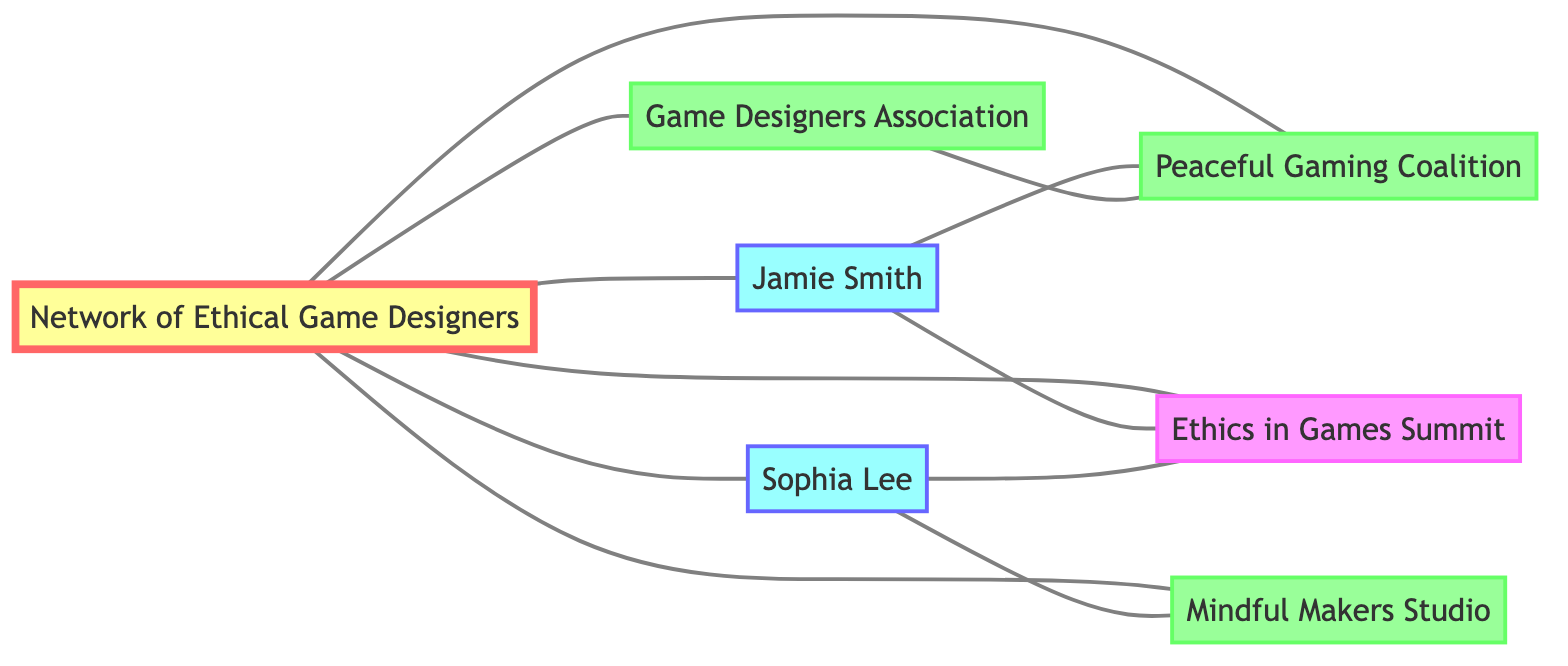What is the total number of nodes in the diagram? The diagram lists a total of seven unique nodes: the Network of Ethical Game Designers, Jamie Smith, Sophia Lee, Ethics in Games Summit, Peaceful Gaming Coalition, Game Designers Association, and Mindful Makers Studio. Therefore, the total number of nodes is seven.
Answer: 7 How many edges connect Jamie Smith to other nodes? Jamie Smith is connected to four different nodes: the Network of Ethical Game Designers, Peaceful Gaming Coalition, Ethics in Games Summit, and the overall game designers network. Counting these connections gives a total of four edges.
Answer: 4 What organization is connected to both Jamie Smith and Sophia Lee? The Peaceful Gaming Coalition is the only organization connected to both Jamie Smith and Sophia Lee, establishing a link between the two designers through this common organization.
Answer: Peaceful Gaming Coalition Do Jamie Smith and Sophia Lee have a direct collaboration? Jamie Smith and Sophia Lee do not have a direct connection to each other; their collaborations are only established through their connections to the Network of Ethical Game Designers and other organizations in the network.
Answer: No Which event is linked to the most designers? Both Jamie Smith and Sophia Lee are connected to the Ethics in Games Summit, making this event linked to two designers, which is more than any other event or organization in the graph.
Answer: Ethics in Games Summit How many connections does the Game Designers Association have? The Game Designers Association is connected to two nodes: the Network of Ethical Game Designers and the Peaceful Gaming Coalition. Thus, it has two total connections in the network.
Answer: 2 Which node has the highest degree of connectivity? The Network of Ethical Game Designers serves as a central node linked to six different entities: all individual designers (Jamie Smith and Sophia Lee) and various organizations (Ethics in Games Summit, Peaceful Gaming Coalition, Game Designers Association, and Mindful Makers Studio), making it the most connected node.
Answer: Network of Ethical Game Designers What type of nodes do Jamie Smith and Sophia Lee represent? Both Jamie Smith and Sophia Lee represent individual game designers in this graph. Their roles in the network are specifically highlighted as individual contributors to ethical game design.
Answer: Person 